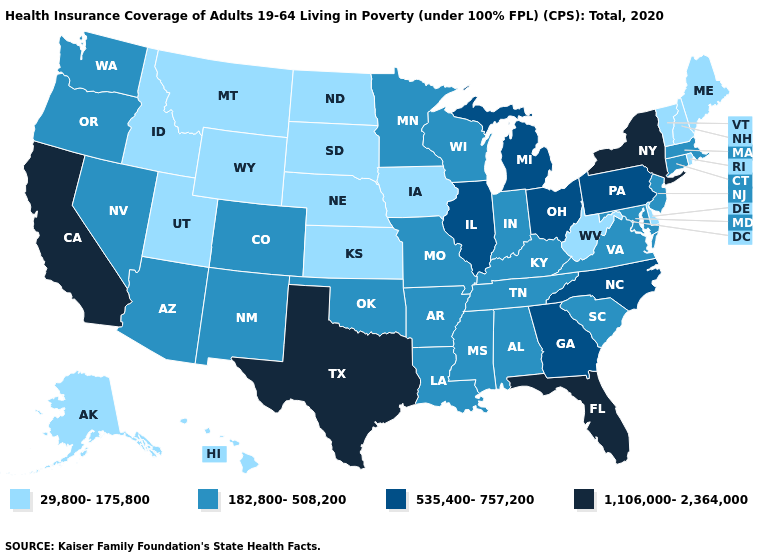Name the states that have a value in the range 29,800-175,800?
Answer briefly. Alaska, Delaware, Hawaii, Idaho, Iowa, Kansas, Maine, Montana, Nebraska, New Hampshire, North Dakota, Rhode Island, South Dakota, Utah, Vermont, West Virginia, Wyoming. What is the value of Tennessee?
Write a very short answer. 182,800-508,200. Is the legend a continuous bar?
Short answer required. No. What is the lowest value in states that border North Carolina?
Be succinct. 182,800-508,200. Does the map have missing data?
Give a very brief answer. No. Among the states that border Pennsylvania , does West Virginia have the highest value?
Be succinct. No. Is the legend a continuous bar?
Quick response, please. No. Name the states that have a value in the range 535,400-757,200?
Be succinct. Georgia, Illinois, Michigan, North Carolina, Ohio, Pennsylvania. Does Virginia have the lowest value in the South?
Keep it brief. No. What is the value of Nevada?
Write a very short answer. 182,800-508,200. What is the lowest value in the USA?
Give a very brief answer. 29,800-175,800. Does Connecticut have the highest value in the Northeast?
Quick response, please. No. Which states have the highest value in the USA?
Short answer required. California, Florida, New York, Texas. 